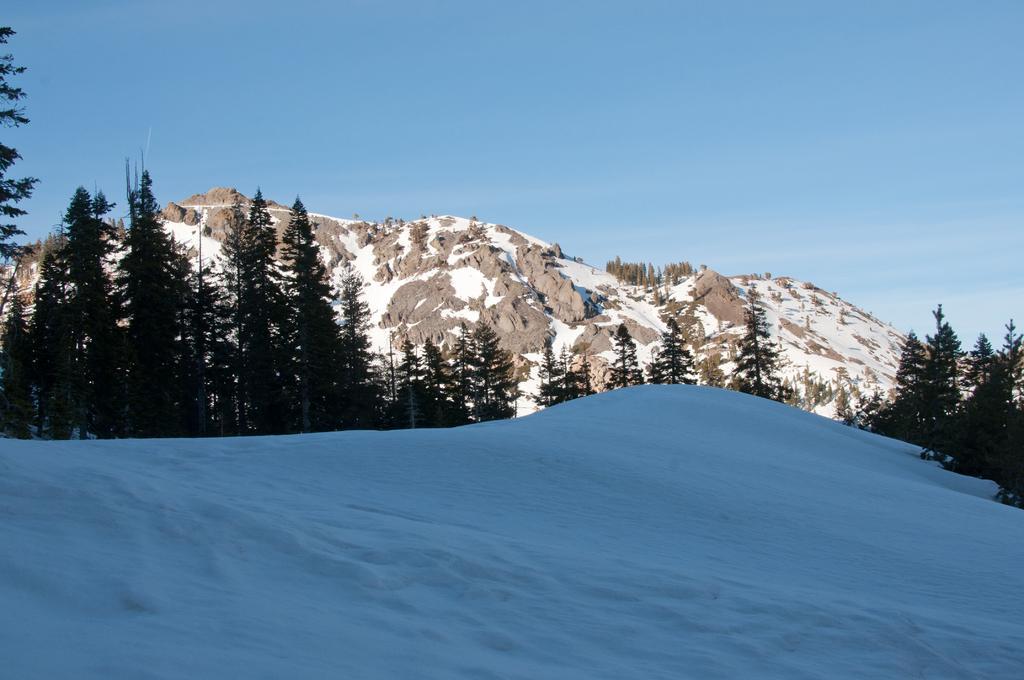Can you describe this image briefly? This picture shows hills and we see trees and snow and we see blue cloudy Sky. 